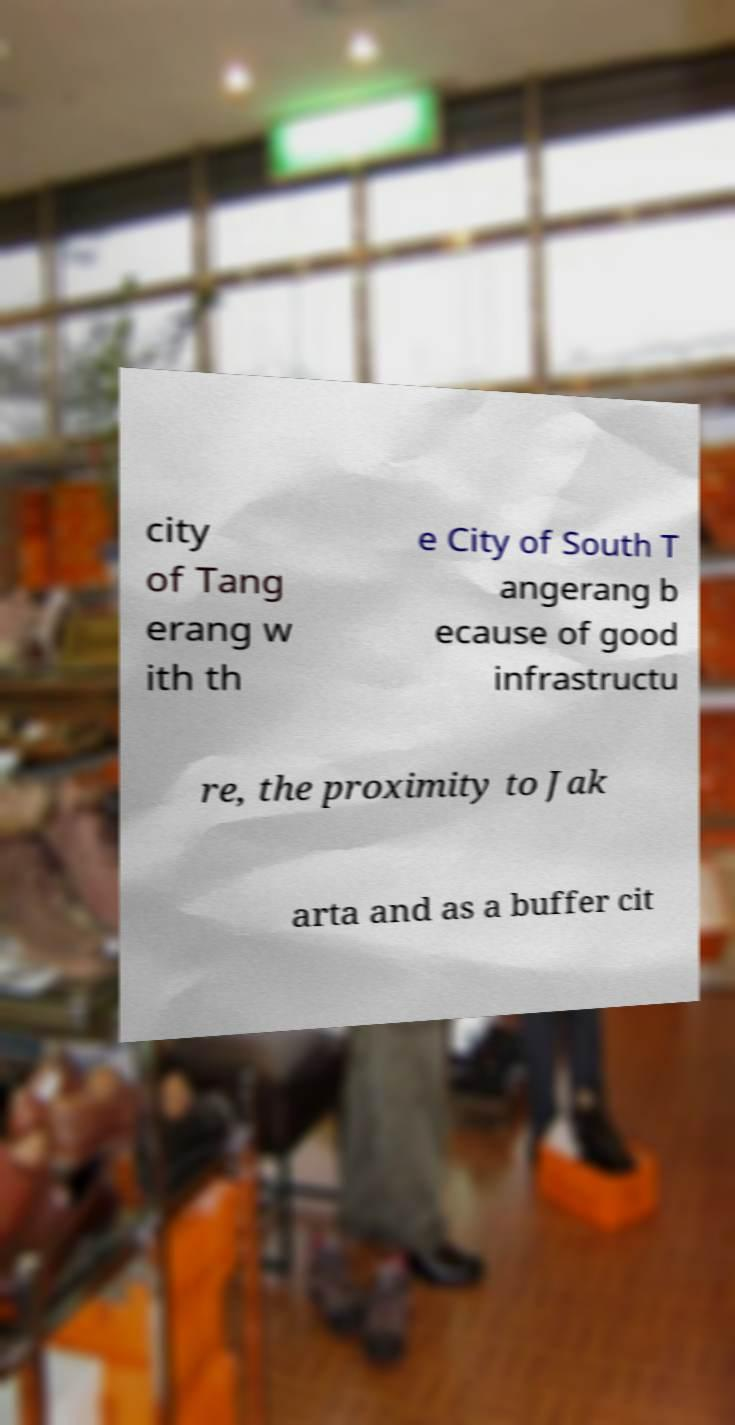For documentation purposes, I need the text within this image transcribed. Could you provide that? city of Tang erang w ith th e City of South T angerang b ecause of good infrastructu re, the proximity to Jak arta and as a buffer cit 